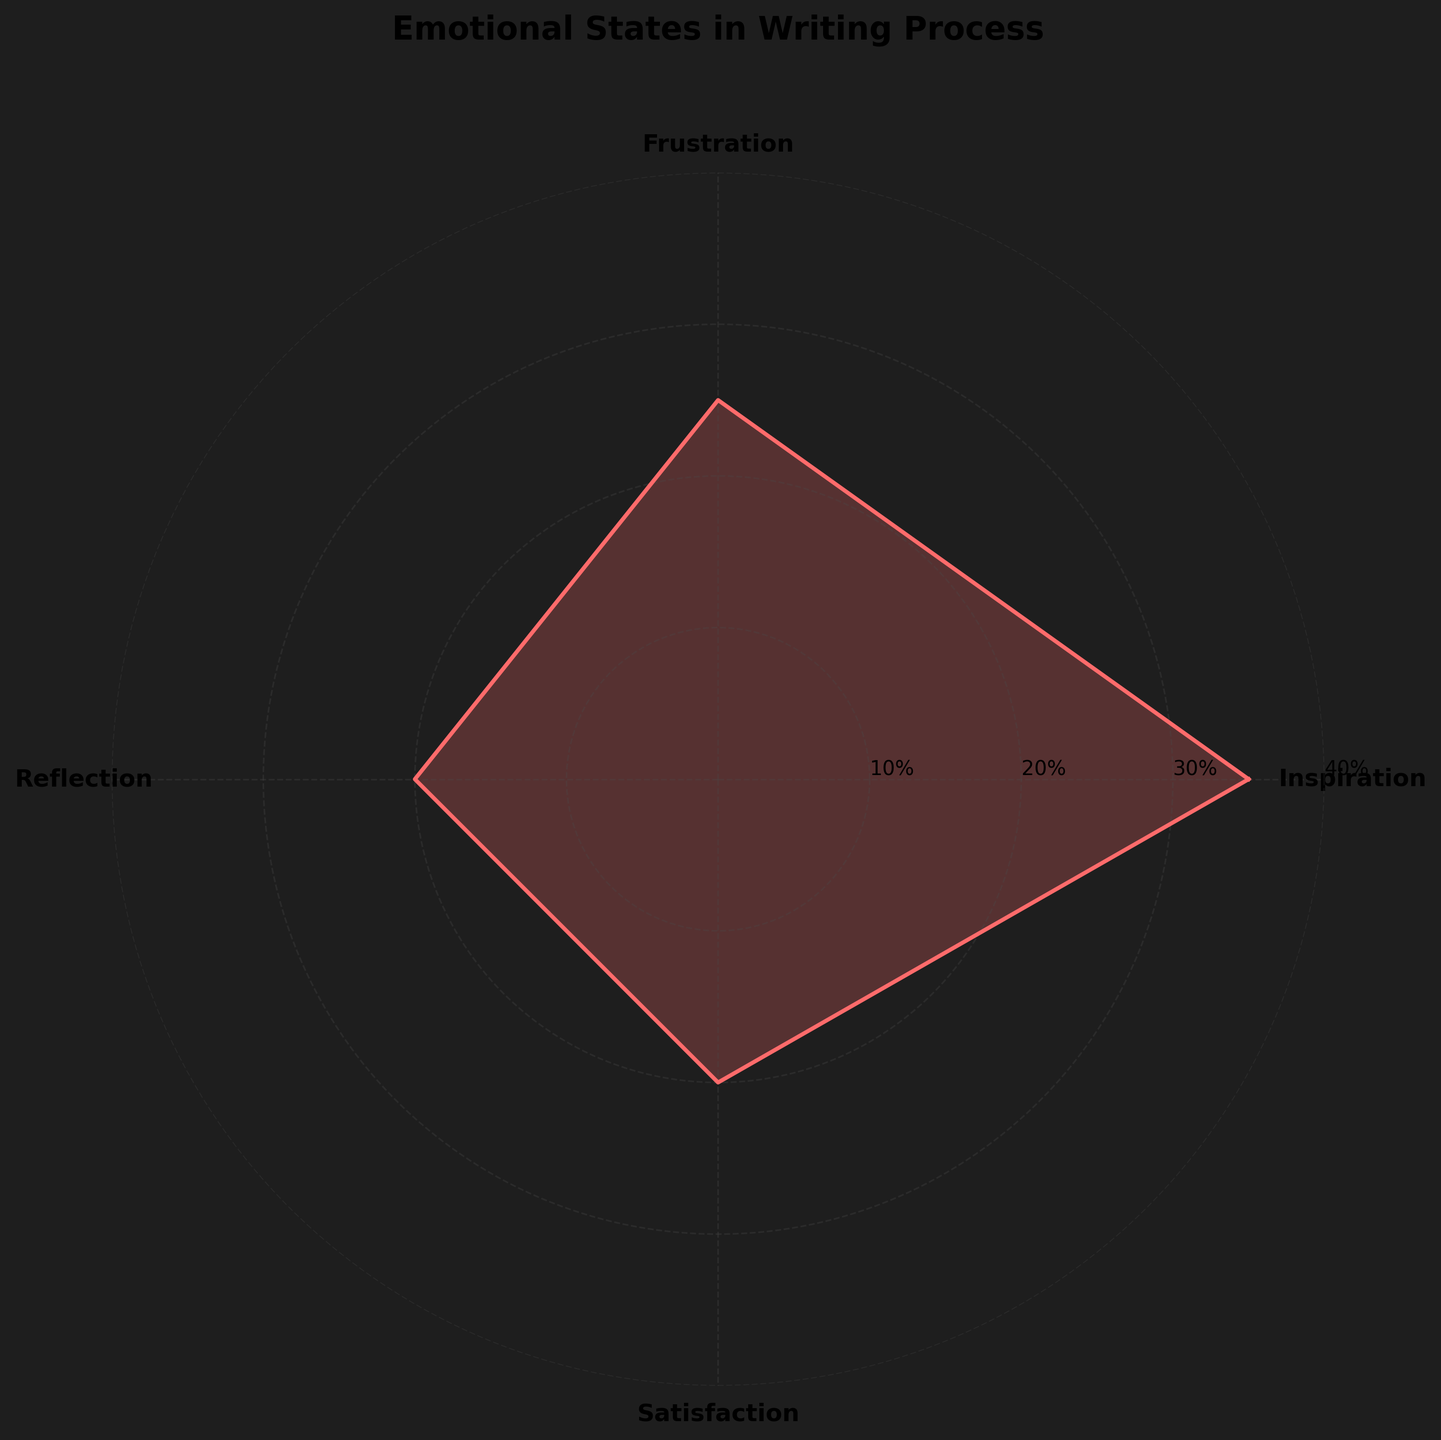What is the title of the figure? The title can be found at the top of the figure in bold text. It reads, "Emotional States in Writing Process".
Answer: Emotional States in Writing Process Which emotional state has the highest proportion? By looking at the length of the segment in the rose chart, the emotional state with the highest proportion is Inspiration which extends the furthest.
Answer: Inspiration What is the combined proportion of Reflection and Satisfaction? Find the segments labeled Reflection and Satisfaction. Both have a proportion of 20%. Adding these together gives 20% + 20% = 40%.
Answer: 40% Which emotional state has the smallest proportion? The shortest segment on the rose chart indicates the smallest proportion which is shared by Reflection and Satisfaction, each with 20%.
Answer: Reflection and Satisfaction How much greater is the proportion of Inspiration compared to Frustration? Inspiration has a proportion of 35% while Frustration has 25%. The difference can be found by subtracting: 35% - 25% = 10%.
Answer: 10% What percentage of the total emotional states do Inspiration and Frustration make up? Inspiration has a proportion of 35% and Frustration has 25%. Adding them together gives 35% + 25% = 60%.
Answer: 60% If you were to order the emotional states from highest to lowest proportion, what would it look like? Looking at the lengths of the segments from longest to shortest, the order would be: Inspiration, Frustration, Reflection, and Satisfaction (The last two are equal).
Answer: Inspiration, Frustration, Reflection, Satisfaction What is the proportion difference between the most and the least experienced emotional states? The most experienced state is Inspiration (35%) and the least experienced are Reflection and Satisfaction (20% each). The difference is 35% - 20% = 15%.
Answer: 15% What is the average proportion of all emotional states? Sum the proportions of all the states: 35% (Inspiration) + 25% (Frustration) + 20% (Reflection) + 20% (Satisfaction) = 100%. Divide by the number of states, which is 4. The average is 100% / 4 = 25%.
Answer: 25% 